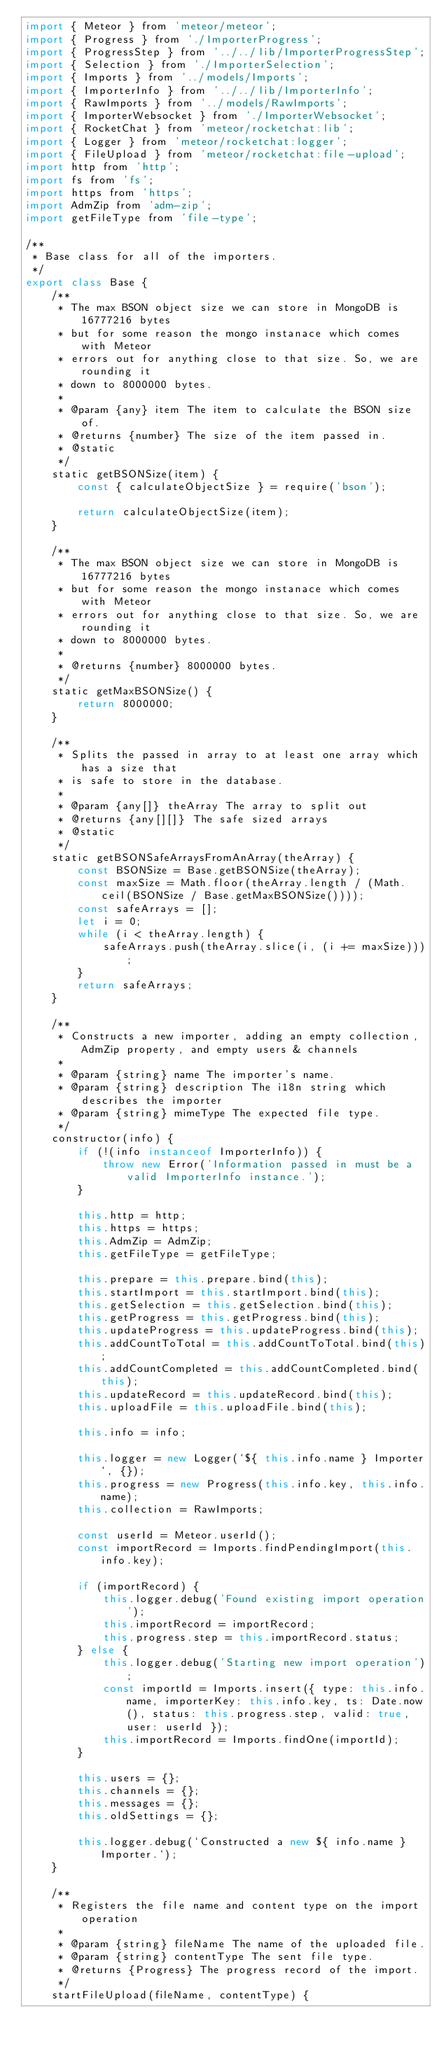Convert code to text. <code><loc_0><loc_0><loc_500><loc_500><_JavaScript_>import { Meteor } from 'meteor/meteor';
import { Progress } from './ImporterProgress';
import { ProgressStep } from '../../lib/ImporterProgressStep';
import { Selection } from './ImporterSelection';
import { Imports } from '../models/Imports';
import { ImporterInfo } from '../../lib/ImporterInfo';
import { RawImports } from '../models/RawImports';
import { ImporterWebsocket } from './ImporterWebsocket';
import { RocketChat } from 'meteor/rocketchat:lib';
import { Logger } from 'meteor/rocketchat:logger';
import { FileUpload } from 'meteor/rocketchat:file-upload';
import http from 'http';
import fs from 'fs';
import https from 'https';
import AdmZip from 'adm-zip';
import getFileType from 'file-type';

/**
 * Base class for all of the importers.
 */
export class Base {
	/**
	 * The max BSON object size we can store in MongoDB is 16777216 bytes
	 * but for some reason the mongo instanace which comes with Meteor
	 * errors out for anything close to that size. So, we are rounding it
	 * down to 8000000 bytes.
	 *
	 * @param {any} item The item to calculate the BSON size of.
	 * @returns {number} The size of the item passed in.
	 * @static
	 */
	static getBSONSize(item) {
		const { calculateObjectSize } = require('bson');

		return calculateObjectSize(item);
	}

	/**
	 * The max BSON object size we can store in MongoDB is 16777216 bytes
	 * but for some reason the mongo instanace which comes with Meteor
	 * errors out for anything close to that size. So, we are rounding it
	 * down to 8000000 bytes.
	 *
	 * @returns {number} 8000000 bytes.
	 */
	static getMaxBSONSize() {
		return 8000000;
	}

	/**
	 * Splits the passed in array to at least one array which has a size that
	 * is safe to store in the database.
	 *
	 * @param {any[]} theArray The array to split out
	 * @returns {any[][]} The safe sized arrays
	 * @static
	 */
	static getBSONSafeArraysFromAnArray(theArray) {
		const BSONSize = Base.getBSONSize(theArray);
		const maxSize = Math.floor(theArray.length / (Math.ceil(BSONSize / Base.getMaxBSONSize())));
		const safeArrays = [];
		let i = 0;
		while (i < theArray.length) {
			safeArrays.push(theArray.slice(i, (i += maxSize)));
		}
		return safeArrays;
	}

	/**
	 * Constructs a new importer, adding an empty collection, AdmZip property, and empty users & channels
	 *
	 * @param {string} name The importer's name.
	 * @param {string} description The i18n string which describes the importer
	 * @param {string} mimeType The expected file type.
	 */
	constructor(info) {
		if (!(info instanceof ImporterInfo)) {
			throw new Error('Information passed in must be a valid ImporterInfo instance.');
		}

		this.http = http;
		this.https = https;
		this.AdmZip = AdmZip;
		this.getFileType = getFileType;

		this.prepare = this.prepare.bind(this);
		this.startImport = this.startImport.bind(this);
		this.getSelection = this.getSelection.bind(this);
		this.getProgress = this.getProgress.bind(this);
		this.updateProgress = this.updateProgress.bind(this);
		this.addCountToTotal = this.addCountToTotal.bind(this);
		this.addCountCompleted = this.addCountCompleted.bind(this);
		this.updateRecord = this.updateRecord.bind(this);
		this.uploadFile = this.uploadFile.bind(this);

		this.info = info;

		this.logger = new Logger(`${ this.info.name } Importer`, {});
		this.progress = new Progress(this.info.key, this.info.name);
		this.collection = RawImports;

		const userId = Meteor.userId();
		const importRecord = Imports.findPendingImport(this.info.key);

		if (importRecord) {
			this.logger.debug('Found existing import operation');
			this.importRecord = importRecord;
			this.progress.step = this.importRecord.status;
		} else {
			this.logger.debug('Starting new import operation');
			const importId = Imports.insert({ type: this.info.name, importerKey: this.info.key, ts: Date.now(), status: this.progress.step, valid: true, user: userId });
			this.importRecord = Imports.findOne(importId);
		}

		this.users = {};
		this.channels = {};
		this.messages = {};
		this.oldSettings = {};

		this.logger.debug(`Constructed a new ${ info.name } Importer.`);
	}

	/**
	 * Registers the file name and content type on the import operation
	 *
	 * @param {string} fileName The name of the uploaded file.
	 * @param {string} contentType The sent file type.
	 * @returns {Progress} The progress record of the import.
	 */
	startFileUpload(fileName, contentType) {</code> 